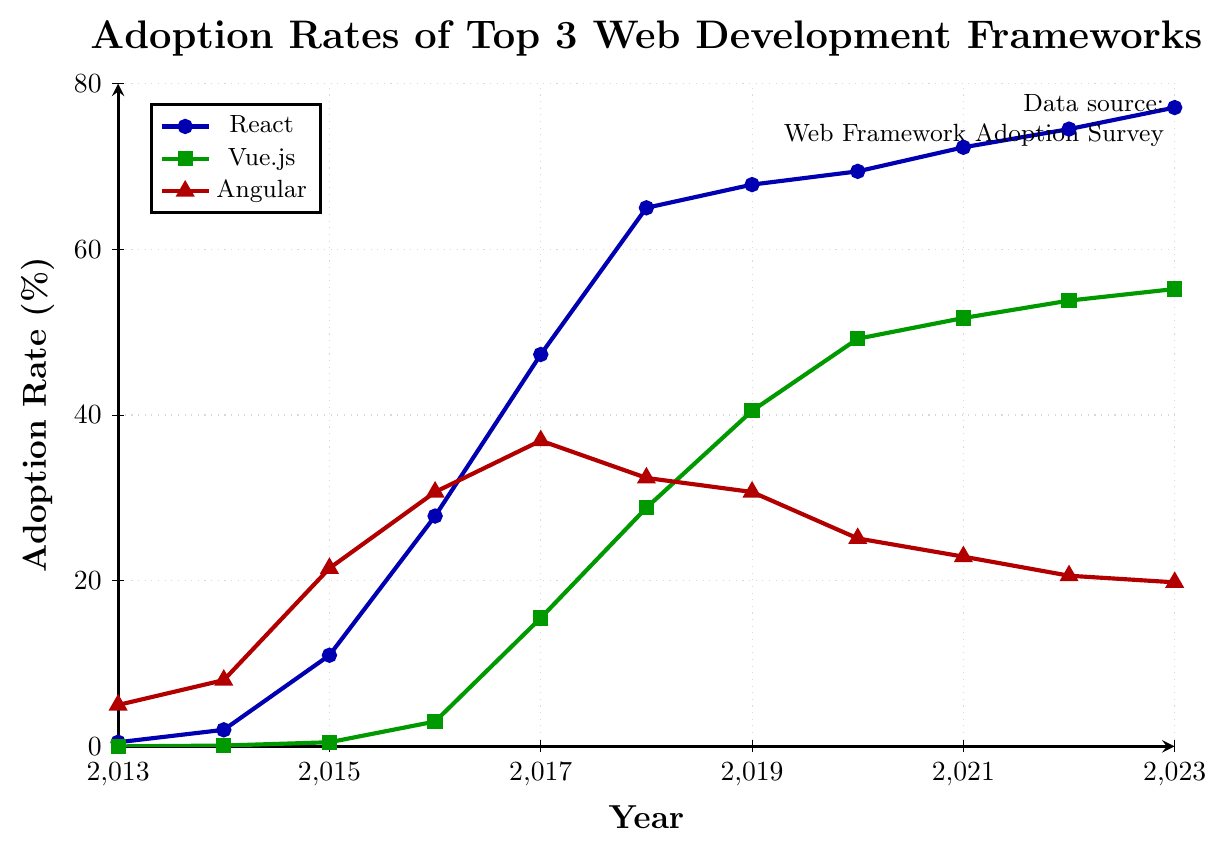Which framework has the highest adoption rate in 2023? By examining the endpoints of the lines in 2023, the line representing React reaches the highest value on the Y-axis (~77.1%).
Answer: React Between 2015 and 2019, which framework shows the most growth in adoption rate? By subtracting the 2015 value from the 2019 value for each framework:
- React: 67.8 - 11 = 56.8
- Vue.js: 40.5 - 0.5 = 40
- Angular: 30.7 - 21.5 = 9.2
React has the highest growth.
Answer: React In which year did Vue.js surpass a 50% adoption rate? Checking the Vue.js line, it crosses the 50% mark between 2020 and 2021; specifically in 2021.
Answer: 2021 Compare the adoption rates of Vue.js and Angular in 2017. Which one is higher and by how much? In 2017, the adoption rates were:
- Vue.js: 15.5%
- Angular: 36.9%
The difference is 36.9 - 15.5 = 21.4%. Angular is higher by 21.4%.
Answer: Angular, 21.4% What is the total change in adoption rate of Svelte from 2017 to 2023? Subtracting the adoption rate of Svelte in 2017 from its rate in 2023:
17.9 - 0.5 = 17.4%
Answer: 17.4% What does the trend of Angular's adoption rate suggest after 2016? From 2016 onwards, Angular’s adoption rate repeatedly falls from 36.9% in 2017 to 19.8% in 2023, indicating a decreasing trend.
Answer: Decreasing Which framework had a higher adoption rate in 2018, Vue.js or React, and by how much? In 2018, the adoption rates were:
- Vue.js: 28.8%
- React: 65%
The difference is 65 - 28.8 = 36.2%. React is higher by 36.2%.
Answer: React, 36.2% Describe the visual characteristics of Angular's trend line between 2016 and 2023. The Angular trend line, marked with red triangles, rises steeply between 2015 and 2016, peaks in 2017, then declines consistently until 2023.
Answer: Rises, peaks, declines Between 2015 and 2018, which framework had the greatest increase in adoption rate: React or Vue.js? By calculating the changes:
- React: 65 - 11 = 54%
- Vue.js: 28.8 - 0.5 = 28.3%
React had the greatest increase.
Answer: React 